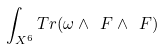<formula> <loc_0><loc_0><loc_500><loc_500>\int _ { X ^ { 6 } } T r ( \omega \wedge \ F \wedge \ F )</formula> 